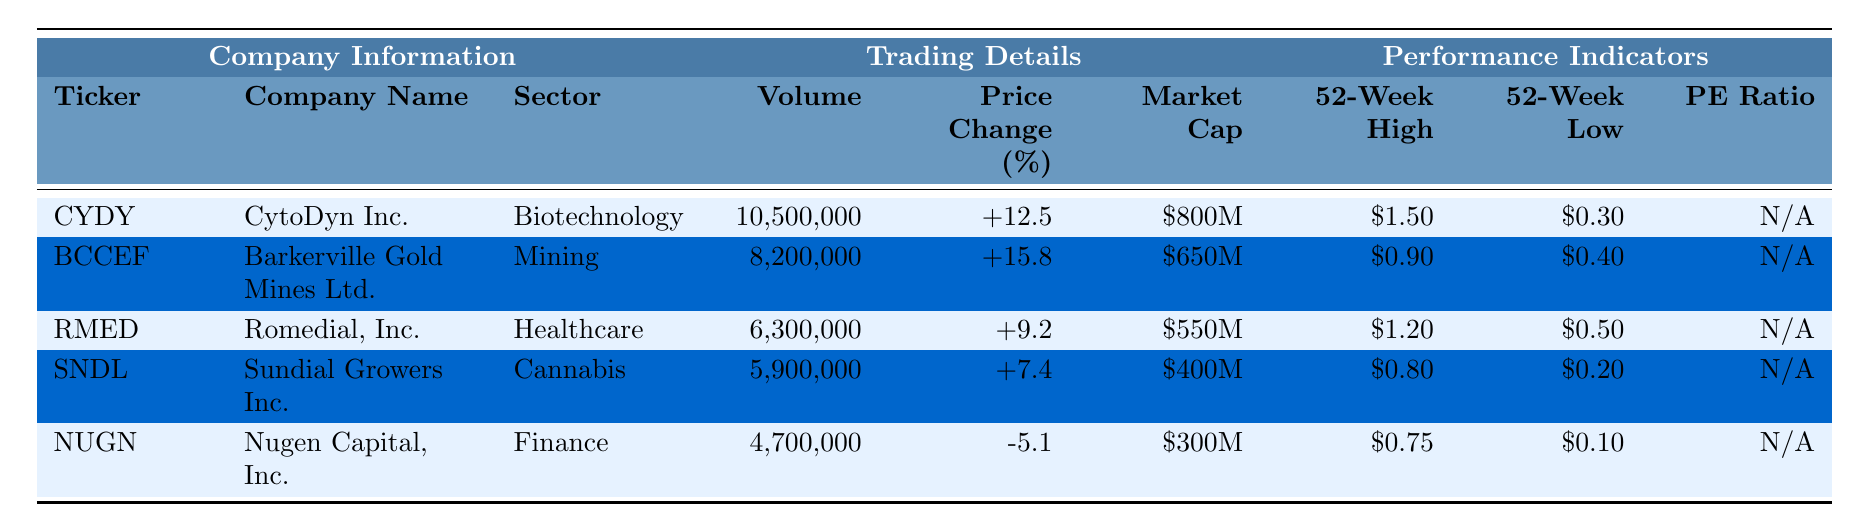What is the ticker symbol for CytoDyn Inc.? The table lists CytoDyn Inc. in the first row under the "Company Information" section, where "Ticker" is provided. The ticker symbol is "CYDY".
Answer: CYDY Which company had the highest trading volume in 2023 Q2? Looking at the "Volume" column, CytoDyn Inc. has the highest trading volume at 10,500,000 shares.
Answer: CytoDyn Inc What percentage price change did Barkerville Gold Mines Ltd. experience? Barkerville Gold Mines Ltd. has a "Price Change (%)" of +15.8, as shown in the table under "Trading Details".
Answer: +15.8% Is there a company in the table with a negative price change? The table shows Nugen Capital, Inc. with a price change of -5.1%, indicating it had a negative change.
Answer: Yes What is the market cap of Romedial, Inc.? The market cap for Romedial, Inc. is listed as $550M in the "Market Cap" column.
Answer: $550M Which company operates in the Cannabis sector? The "Sector" column indicates that Sundial Growers Inc. operates in the Cannabis sector.
Answer: Sundial Growers Inc What is the difference between the 52-week high and the 52-week low for SNDL? The 52-week high for Sundial Growers Inc. (SNDL) is $0.80 and the low is $0.20. The difference is $0.80 - $0.20 = $0.60.
Answer: $0.60 How many companies have a PE Ratio listed as N/A? All the listed companies in the table have their PE Ratio marked as N/A, totaling 5 companies.
Answer: 5 Which company has the lowest market cap among the listed penny stocks? Nugen Capital, Inc. has the lowest market cap of $300M in the "Market Cap" section.
Answer: Nugen Capital, Inc If you average the price changes of the companies listed, does it exceed 10%? The price changes are +12.5, +15.8, +9.2, +7.4, and -5.1. Adding these gives +39.8. Dividing by 5 for the average: 39.8 / 5 = 7.96%, which does not exceed 10%.
Answer: No 